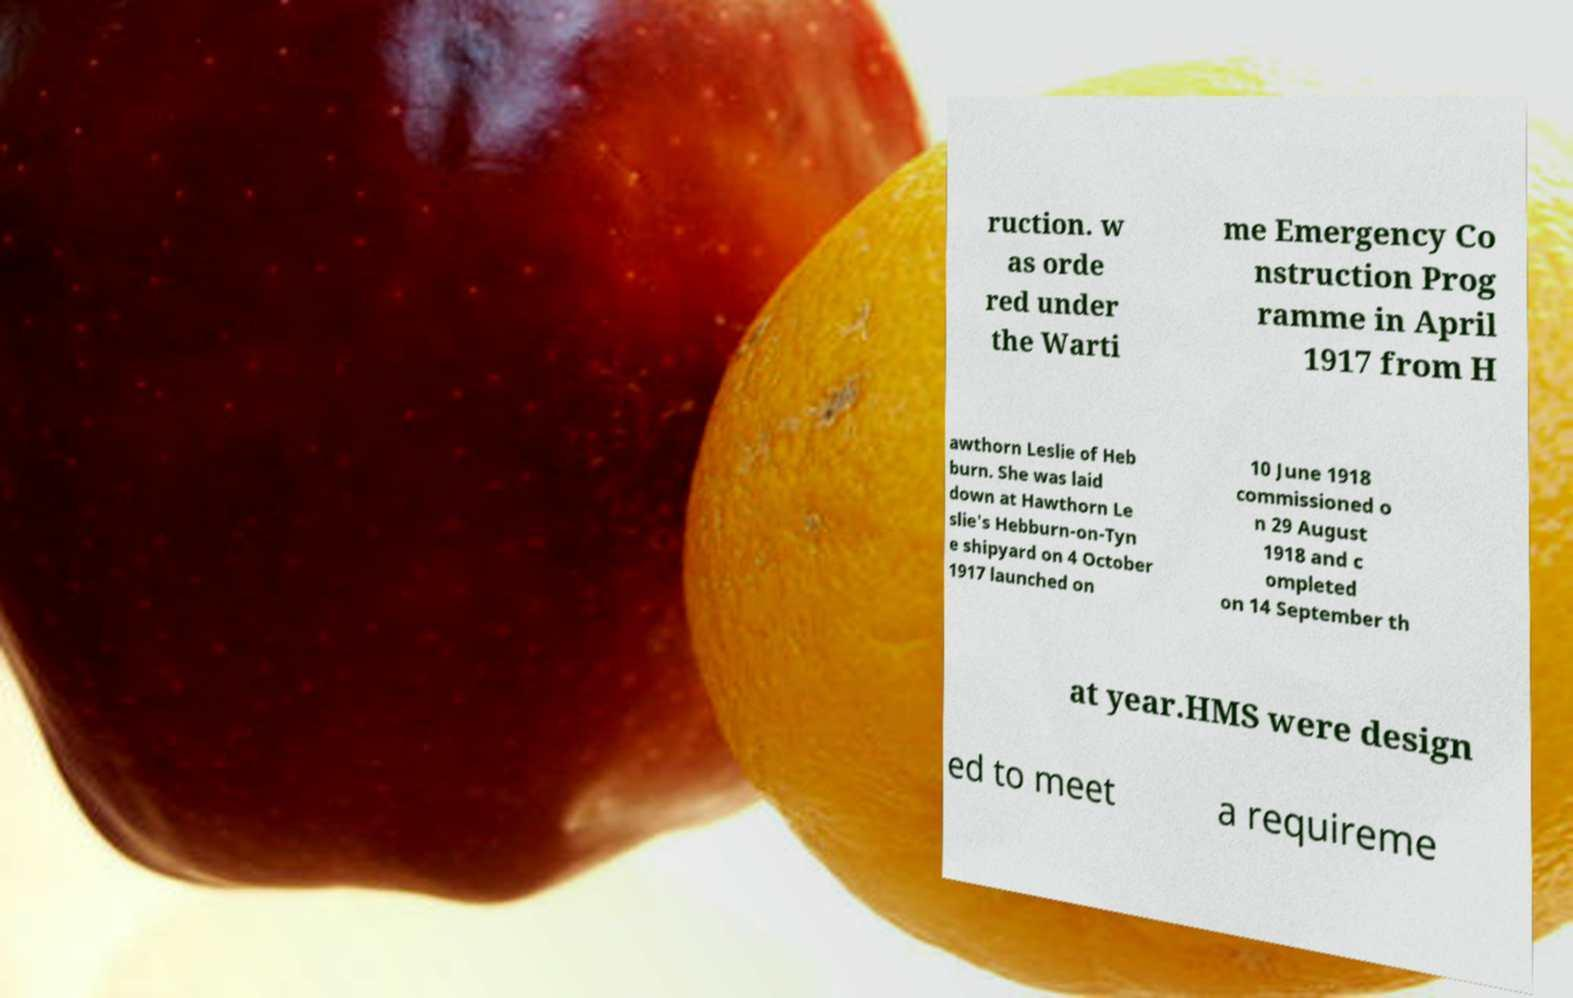Please read and relay the text visible in this image. What does it say? ruction. w as orde red under the Warti me Emergency Co nstruction Prog ramme in April 1917 from H awthorn Leslie of Heb burn. She was laid down at Hawthorn Le slie's Hebburn-on-Tyn e shipyard on 4 October 1917 launched on 10 June 1918 commissioned o n 29 August 1918 and c ompleted on 14 September th at year.HMS were design ed to meet a requireme 